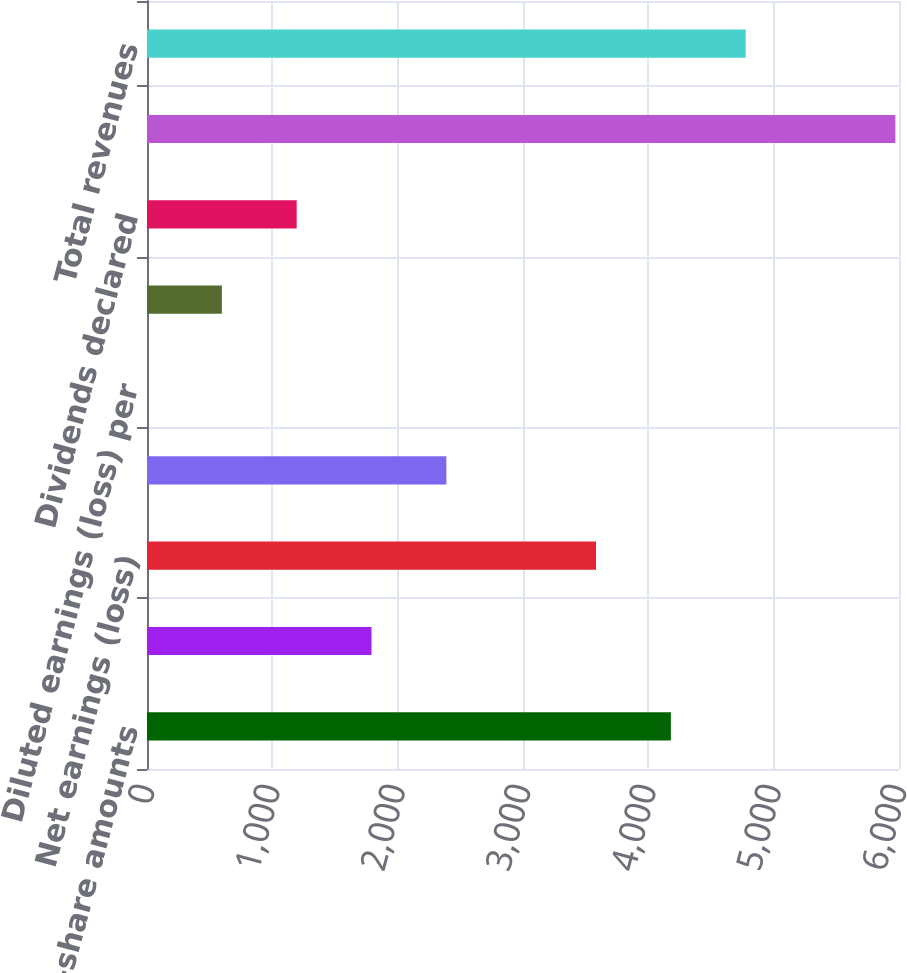Convert chart to OTSL. <chart><loc_0><loc_0><loc_500><loc_500><bar_chart><fcel>(In millions per-share amounts<fcel>Earnings (loss) from<fcel>Net earnings (loss)<fcel>Less net earnings (loss)<fcel>Diluted earnings (loss) per<fcel>Basic earnings (loss) per<fcel>Dividends declared<fcel>Gross profit from sales<fcel>Total revenues<nl><fcel>4179.75<fcel>1791.39<fcel>3582.66<fcel>2388.48<fcel>0.12<fcel>597.21<fcel>1194.3<fcel>5971<fcel>4776.84<nl></chart> 